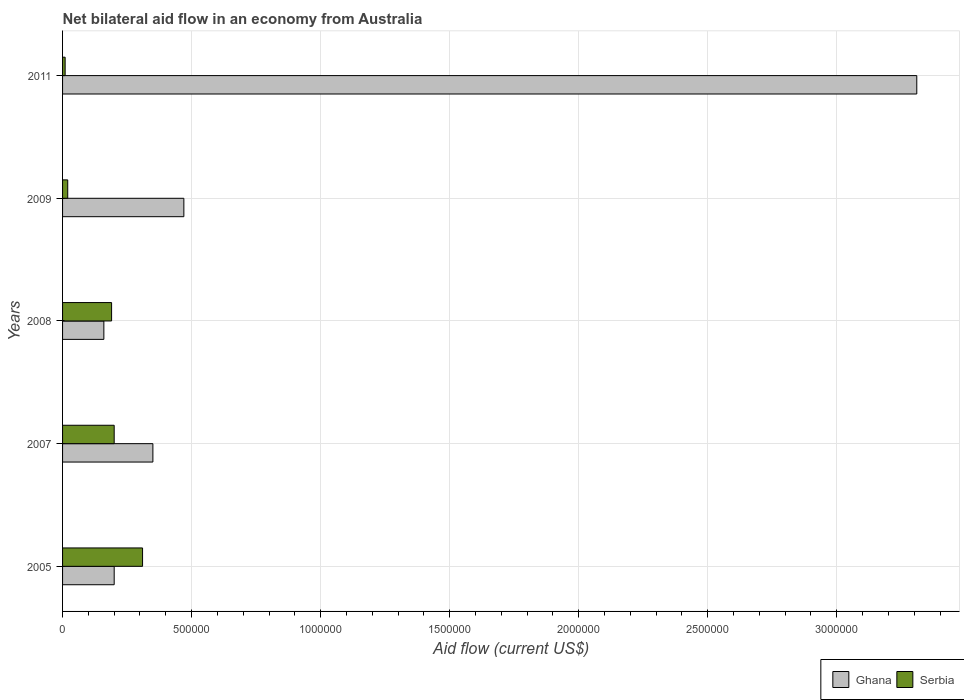How many different coloured bars are there?
Offer a very short reply. 2. How many groups of bars are there?
Your answer should be very brief. 5. Are the number of bars per tick equal to the number of legend labels?
Provide a succinct answer. Yes. Are the number of bars on each tick of the Y-axis equal?
Your response must be concise. Yes. What is the label of the 4th group of bars from the top?
Offer a very short reply. 2007. In how many cases, is the number of bars for a given year not equal to the number of legend labels?
Your answer should be compact. 0. Across all years, what is the maximum net bilateral aid flow in Serbia?
Your response must be concise. 3.10e+05. In which year was the net bilateral aid flow in Serbia maximum?
Offer a very short reply. 2005. What is the total net bilateral aid flow in Serbia in the graph?
Provide a succinct answer. 7.30e+05. What is the difference between the net bilateral aid flow in Serbia in 2009 and that in 2011?
Keep it short and to the point. 10000. What is the difference between the net bilateral aid flow in Ghana in 2009 and the net bilateral aid flow in Serbia in 2008?
Ensure brevity in your answer.  2.80e+05. What is the average net bilateral aid flow in Ghana per year?
Ensure brevity in your answer.  8.98e+05. In the year 2005, what is the difference between the net bilateral aid flow in Ghana and net bilateral aid flow in Serbia?
Your answer should be compact. -1.10e+05. What is the ratio of the net bilateral aid flow in Serbia in 2008 to that in 2009?
Your answer should be compact. 9.5. Is the net bilateral aid flow in Serbia in 2009 less than that in 2011?
Provide a short and direct response. No. In how many years, is the net bilateral aid flow in Serbia greater than the average net bilateral aid flow in Serbia taken over all years?
Keep it short and to the point. 3. What does the 2nd bar from the bottom in 2011 represents?
Your answer should be very brief. Serbia. How many bars are there?
Your answer should be very brief. 10. Are all the bars in the graph horizontal?
Provide a short and direct response. Yes. Where does the legend appear in the graph?
Offer a terse response. Bottom right. What is the title of the graph?
Your answer should be very brief. Net bilateral aid flow in an economy from Australia. What is the label or title of the X-axis?
Provide a short and direct response. Aid flow (current US$). What is the Aid flow (current US$) in Serbia in 2007?
Offer a very short reply. 2.00e+05. What is the Aid flow (current US$) of Ghana in 2008?
Your response must be concise. 1.60e+05. What is the Aid flow (current US$) in Serbia in 2008?
Offer a terse response. 1.90e+05. What is the Aid flow (current US$) of Ghana in 2011?
Provide a succinct answer. 3.31e+06. Across all years, what is the maximum Aid flow (current US$) of Ghana?
Make the answer very short. 3.31e+06. Across all years, what is the maximum Aid flow (current US$) of Serbia?
Make the answer very short. 3.10e+05. What is the total Aid flow (current US$) in Ghana in the graph?
Your answer should be very brief. 4.49e+06. What is the total Aid flow (current US$) in Serbia in the graph?
Give a very brief answer. 7.30e+05. What is the difference between the Aid flow (current US$) of Ghana in 2005 and that in 2007?
Provide a succinct answer. -1.50e+05. What is the difference between the Aid flow (current US$) of Ghana in 2005 and that in 2008?
Ensure brevity in your answer.  4.00e+04. What is the difference between the Aid flow (current US$) in Serbia in 2005 and that in 2009?
Give a very brief answer. 2.90e+05. What is the difference between the Aid flow (current US$) of Ghana in 2005 and that in 2011?
Keep it short and to the point. -3.11e+06. What is the difference between the Aid flow (current US$) of Serbia in 2007 and that in 2008?
Make the answer very short. 10000. What is the difference between the Aid flow (current US$) of Serbia in 2007 and that in 2009?
Ensure brevity in your answer.  1.80e+05. What is the difference between the Aid flow (current US$) of Ghana in 2007 and that in 2011?
Make the answer very short. -2.96e+06. What is the difference between the Aid flow (current US$) of Ghana in 2008 and that in 2009?
Offer a terse response. -3.10e+05. What is the difference between the Aid flow (current US$) in Serbia in 2008 and that in 2009?
Provide a succinct answer. 1.70e+05. What is the difference between the Aid flow (current US$) in Ghana in 2008 and that in 2011?
Your answer should be compact. -3.15e+06. What is the difference between the Aid flow (current US$) in Ghana in 2009 and that in 2011?
Your answer should be compact. -2.84e+06. What is the difference between the Aid flow (current US$) in Ghana in 2005 and the Aid flow (current US$) in Serbia in 2009?
Your answer should be very brief. 1.80e+05. What is the difference between the Aid flow (current US$) in Ghana in 2005 and the Aid flow (current US$) in Serbia in 2011?
Offer a very short reply. 1.90e+05. What is the difference between the Aid flow (current US$) of Ghana in 2007 and the Aid flow (current US$) of Serbia in 2008?
Provide a succinct answer. 1.60e+05. What is the difference between the Aid flow (current US$) of Ghana in 2007 and the Aid flow (current US$) of Serbia in 2009?
Provide a succinct answer. 3.30e+05. What is the difference between the Aid flow (current US$) in Ghana in 2007 and the Aid flow (current US$) in Serbia in 2011?
Make the answer very short. 3.40e+05. What is the difference between the Aid flow (current US$) of Ghana in 2008 and the Aid flow (current US$) of Serbia in 2011?
Your response must be concise. 1.50e+05. What is the average Aid flow (current US$) of Ghana per year?
Your answer should be very brief. 8.98e+05. What is the average Aid flow (current US$) in Serbia per year?
Your answer should be compact. 1.46e+05. In the year 2005, what is the difference between the Aid flow (current US$) in Ghana and Aid flow (current US$) in Serbia?
Offer a terse response. -1.10e+05. In the year 2008, what is the difference between the Aid flow (current US$) in Ghana and Aid flow (current US$) in Serbia?
Keep it short and to the point. -3.00e+04. In the year 2011, what is the difference between the Aid flow (current US$) of Ghana and Aid flow (current US$) of Serbia?
Your response must be concise. 3.30e+06. What is the ratio of the Aid flow (current US$) in Ghana in 2005 to that in 2007?
Ensure brevity in your answer.  0.57. What is the ratio of the Aid flow (current US$) of Serbia in 2005 to that in 2007?
Provide a short and direct response. 1.55. What is the ratio of the Aid flow (current US$) of Ghana in 2005 to that in 2008?
Keep it short and to the point. 1.25. What is the ratio of the Aid flow (current US$) of Serbia in 2005 to that in 2008?
Ensure brevity in your answer.  1.63. What is the ratio of the Aid flow (current US$) of Ghana in 2005 to that in 2009?
Your response must be concise. 0.43. What is the ratio of the Aid flow (current US$) in Serbia in 2005 to that in 2009?
Keep it short and to the point. 15.5. What is the ratio of the Aid flow (current US$) of Ghana in 2005 to that in 2011?
Offer a terse response. 0.06. What is the ratio of the Aid flow (current US$) in Ghana in 2007 to that in 2008?
Offer a very short reply. 2.19. What is the ratio of the Aid flow (current US$) in Serbia in 2007 to that in 2008?
Ensure brevity in your answer.  1.05. What is the ratio of the Aid flow (current US$) in Ghana in 2007 to that in 2009?
Provide a short and direct response. 0.74. What is the ratio of the Aid flow (current US$) in Serbia in 2007 to that in 2009?
Provide a succinct answer. 10. What is the ratio of the Aid flow (current US$) in Ghana in 2007 to that in 2011?
Your response must be concise. 0.11. What is the ratio of the Aid flow (current US$) in Serbia in 2007 to that in 2011?
Your answer should be very brief. 20. What is the ratio of the Aid flow (current US$) of Ghana in 2008 to that in 2009?
Your answer should be very brief. 0.34. What is the ratio of the Aid flow (current US$) in Serbia in 2008 to that in 2009?
Offer a terse response. 9.5. What is the ratio of the Aid flow (current US$) in Ghana in 2008 to that in 2011?
Provide a short and direct response. 0.05. What is the ratio of the Aid flow (current US$) in Ghana in 2009 to that in 2011?
Provide a short and direct response. 0.14. What is the ratio of the Aid flow (current US$) in Serbia in 2009 to that in 2011?
Provide a succinct answer. 2. What is the difference between the highest and the second highest Aid flow (current US$) of Ghana?
Ensure brevity in your answer.  2.84e+06. What is the difference between the highest and the second highest Aid flow (current US$) of Serbia?
Offer a terse response. 1.10e+05. What is the difference between the highest and the lowest Aid flow (current US$) of Ghana?
Give a very brief answer. 3.15e+06. What is the difference between the highest and the lowest Aid flow (current US$) in Serbia?
Ensure brevity in your answer.  3.00e+05. 